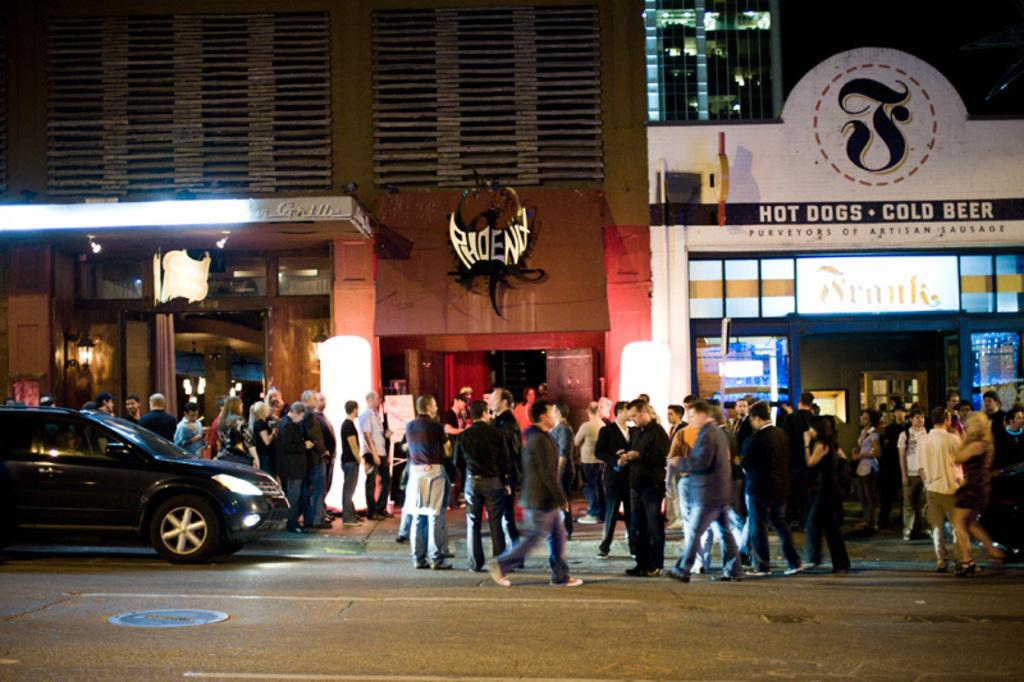What are the people in the image doing? Some people are walking, and others are standing in the image. Can you describe the vehicle in the image? There is a car on the left side of the image. What can be seen in the background of the image? There are buildings and boards visible in the background of the image. Where is the pest hiding in the image? There is no pest present in the image. What type of locket can be seen around the neck of the person in the image? There is no locket visible around the neck of any person in the image. 